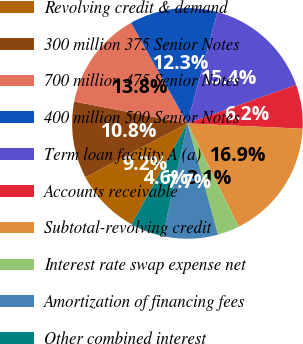<chart> <loc_0><loc_0><loc_500><loc_500><pie_chart><fcel>Revolving credit & demand<fcel>300 million 375 Senior Notes<fcel>700 million 475 Senior Notes<fcel>400 million 500 Senior Notes<fcel>Term loan facility A (a)<fcel>Accounts receivable<fcel>Subtotal-revolving credit<fcel>Interest rate swap expense net<fcel>Amortization of financing fees<fcel>Other combined interest<nl><fcel>9.23%<fcel>10.77%<fcel>13.84%<fcel>12.31%<fcel>15.38%<fcel>6.16%<fcel>16.92%<fcel>3.08%<fcel>7.69%<fcel>4.62%<nl></chart> 